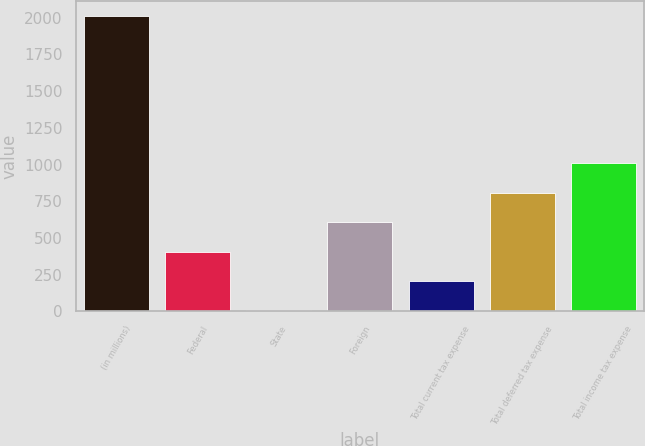Convert chart to OTSL. <chart><loc_0><loc_0><loc_500><loc_500><bar_chart><fcel>(in millions)<fcel>Federal<fcel>State<fcel>Foreign<fcel>Total current tax expense<fcel>Total deferred tax expense<fcel>Total income tax expense<nl><fcel>2013<fcel>407.4<fcel>6<fcel>608.1<fcel>206.7<fcel>808.8<fcel>1009.5<nl></chart> 